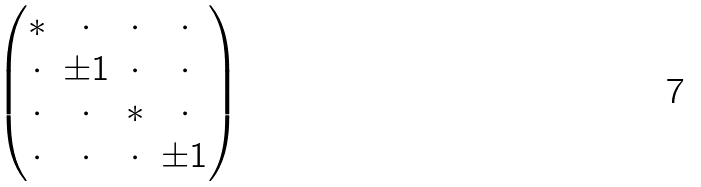Convert formula to latex. <formula><loc_0><loc_0><loc_500><loc_500>\begin{pmatrix} * & \cdot & \cdot & \cdot \\ \cdot & \pm 1 & \cdot & \cdot \\ \cdot & \cdot & * & \cdot \\ \cdot & \cdot & \cdot & \pm 1 \end{pmatrix}</formula> 